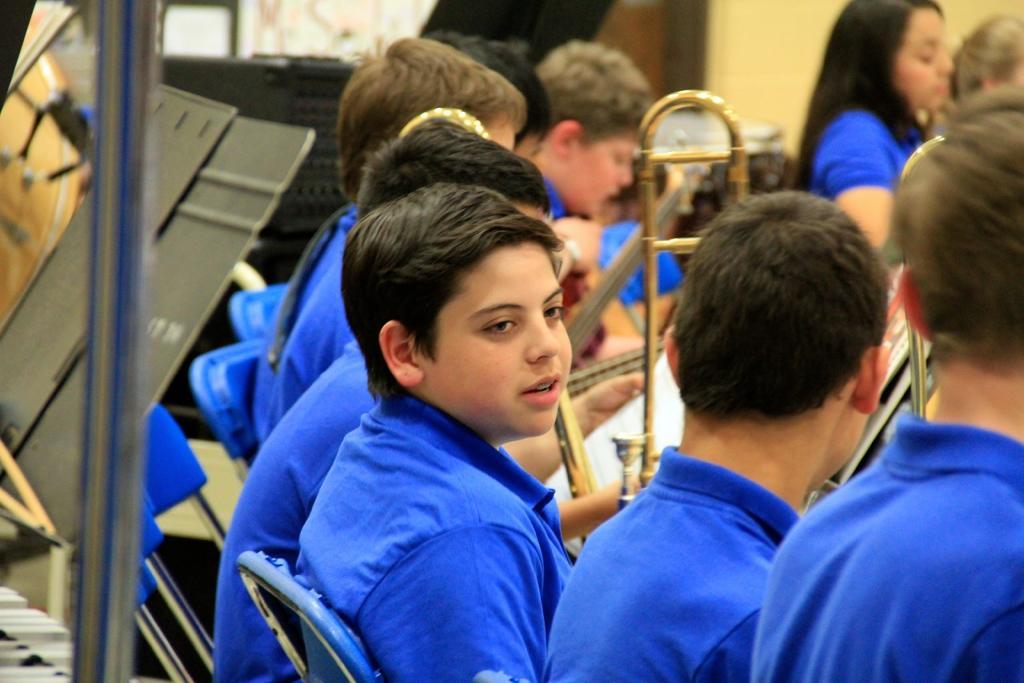Could you give a brief overview of what you see in this image? In this image there are boys and girls sitting on the chairs. In the top right there is a wall behind them. To the left there is a metal rod. Behind it there are a few objects. 